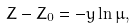<formula> <loc_0><loc_0><loc_500><loc_500>Z - Z _ { 0 } = - y \ln \mu ,</formula> 